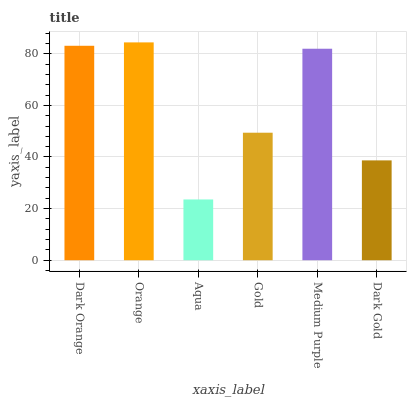Is Aqua the minimum?
Answer yes or no. Yes. Is Orange the maximum?
Answer yes or no. Yes. Is Orange the minimum?
Answer yes or no. No. Is Aqua the maximum?
Answer yes or no. No. Is Orange greater than Aqua?
Answer yes or no. Yes. Is Aqua less than Orange?
Answer yes or no. Yes. Is Aqua greater than Orange?
Answer yes or no. No. Is Orange less than Aqua?
Answer yes or no. No. Is Medium Purple the high median?
Answer yes or no. Yes. Is Gold the low median?
Answer yes or no. Yes. Is Dark Gold the high median?
Answer yes or no. No. Is Medium Purple the low median?
Answer yes or no. No. 